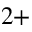<formula> <loc_0><loc_0><loc_500><loc_500>^ { 2 + }</formula> 